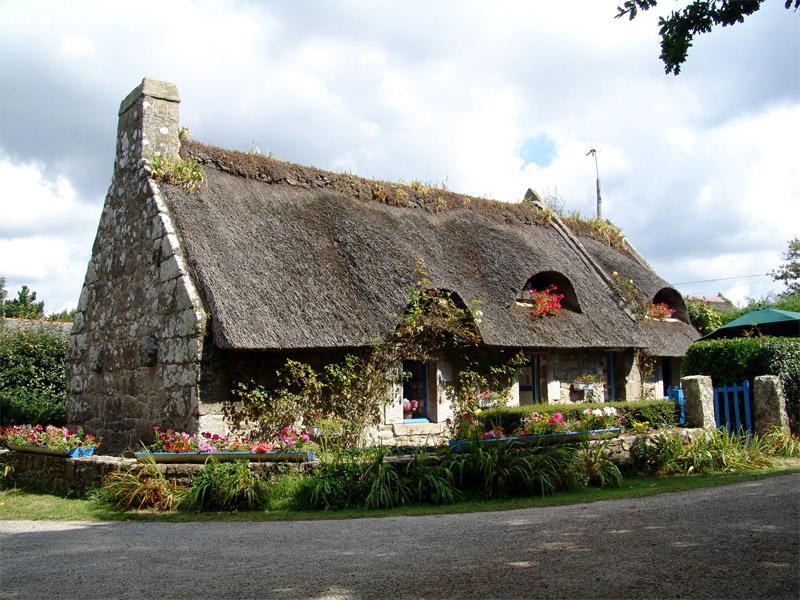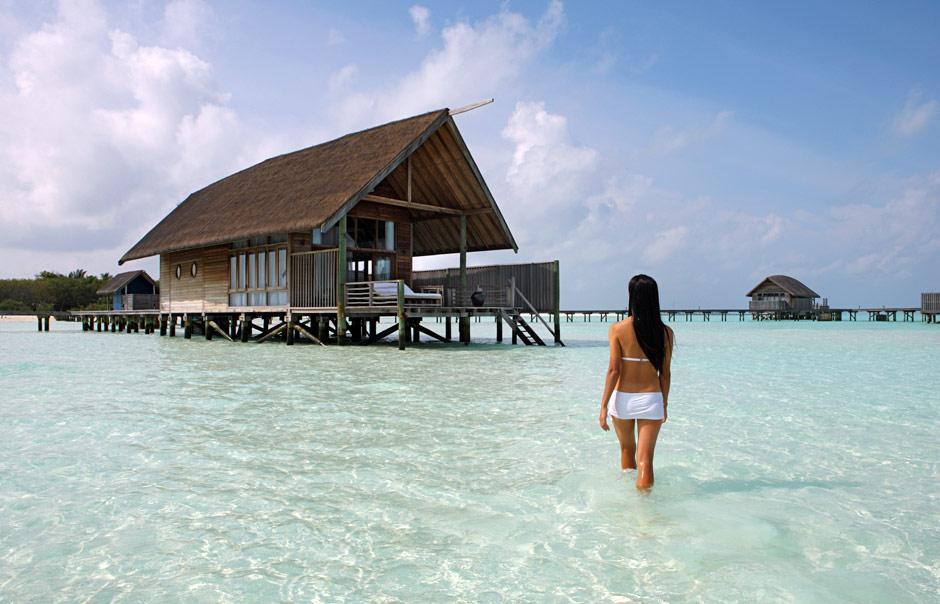The first image is the image on the left, the second image is the image on the right. For the images displayed, is the sentence "Left and right images feature thatch-roofed buildings on a beach, and the right image includes a curving swimming pool." factually correct? Answer yes or no. No. The first image is the image on the left, the second image is the image on the right. Evaluate the accuracy of this statement regarding the images: "A pier crosses the water in the image on the left.". Is it true? Answer yes or no. No. 